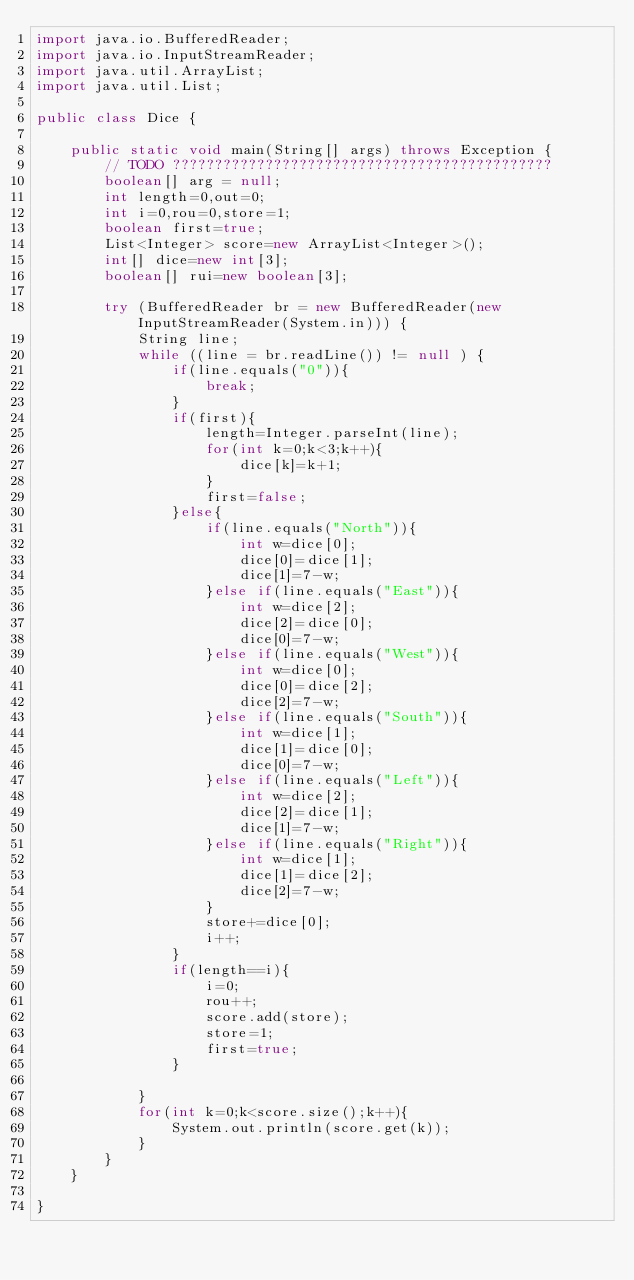<code> <loc_0><loc_0><loc_500><loc_500><_Java_>import java.io.BufferedReader;
import java.io.InputStreamReader;
import java.util.ArrayList;
import java.util.List;

public class Dice {

	public static void main(String[] args) throws Exception {
		// TODO ?????????????????????????????????????????????
		boolean[] arg = null;
		int length=0,out=0;
        int i=0,rou=0,store=1;
        boolean first=true;
        List<Integer> score=new ArrayList<Integer>();
        int[] dice=new int[3];
        boolean[] rui=new boolean[3];

		try (BufferedReader br = new BufferedReader(new InputStreamReader(System.in))) {
            String line;
            while ((line = br.readLine()) != null ) {
            	if(line.equals("0")){
                	break;
                }
            	if(first){
            		length=Integer.parseInt(line);
            		for(int k=0;k<3;k++){
            			dice[k]=k+1;
            		}
            		first=false;
            	}else{
            		if(line.equals("North")){
            			int w=dice[0];
            			dice[0]=dice[1];
            			dice[1]=7-w;
            		}else if(line.equals("East")){
            			int w=dice[2];
            			dice[2]=dice[0];
            			dice[0]=7-w;
            		}else if(line.equals("West")){
            			int w=dice[0];
            			dice[0]=dice[2];
            			dice[2]=7-w;
            		}else if(line.equals("South")){
            			int w=dice[1];
            			dice[1]=dice[0];
            			dice[0]=7-w;
            		}else if(line.equals("Left")){
            			int w=dice[2];
            			dice[2]=dice[1];
            			dice[1]=7-w;
            		}else if(line.equals("Right")){
            			int w=dice[1];
            			dice[1]=dice[2];
            			dice[2]=7-w;
            		}
            		store+=dice[0];
            		i++;
            	}
            	if(length==i){
            		i=0;
            		rou++;
            		score.add(store);
            		store=1;
            		first=true;
            	}

            }
            for(int k=0;k<score.size();k++){
            	System.out.println(score.get(k));
            }
		}
	}

}</code> 